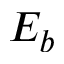Convert formula to latex. <formula><loc_0><loc_0><loc_500><loc_500>E _ { b }</formula> 